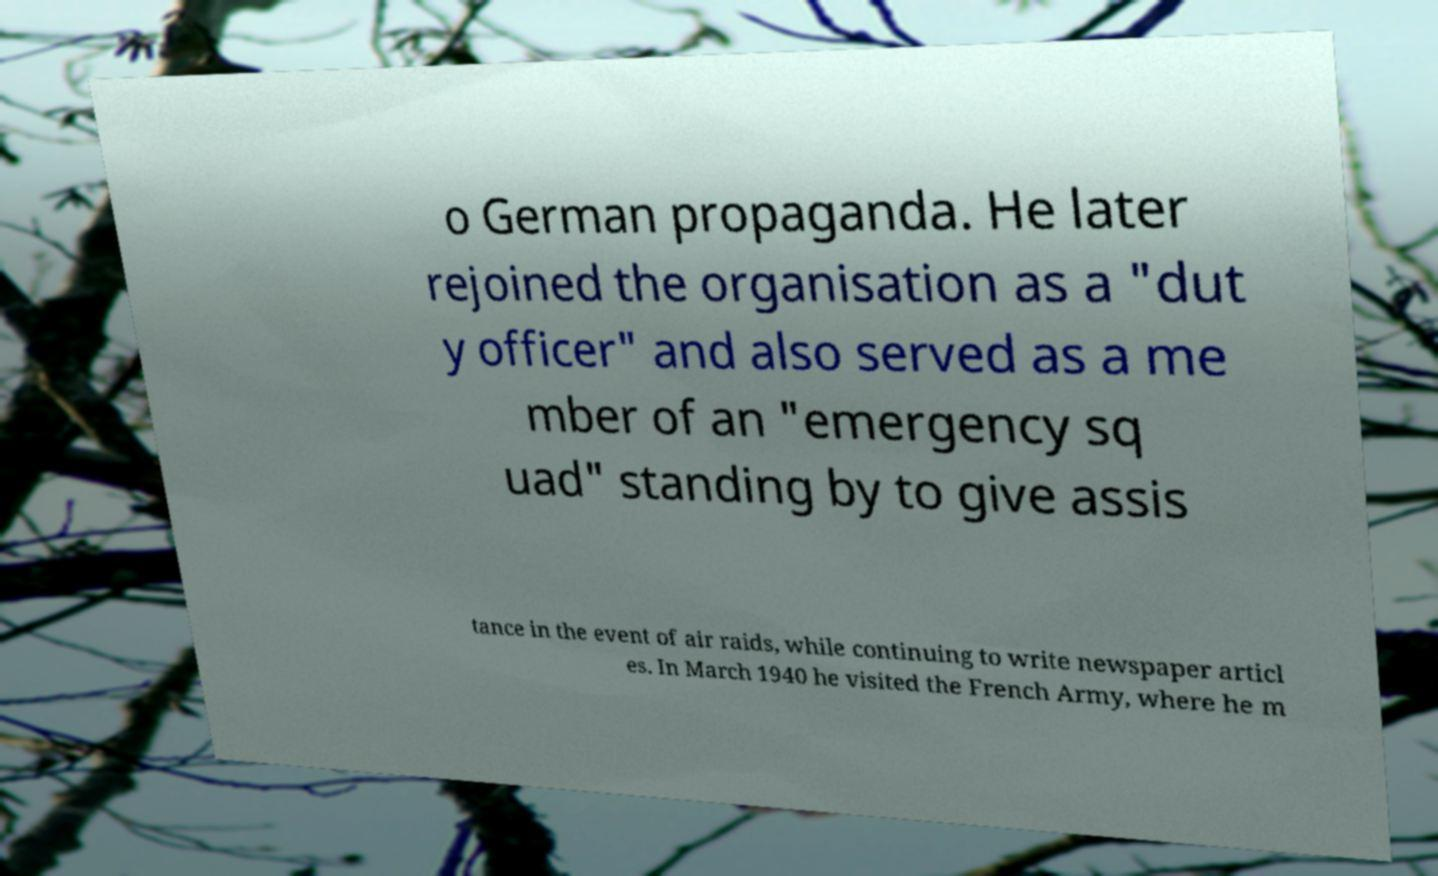What messages or text are displayed in this image? I need them in a readable, typed format. o German propaganda. He later rejoined the organisation as a "dut y officer" and also served as a me mber of an "emergency sq uad" standing by to give assis tance in the event of air raids, while continuing to write newspaper articl es. In March 1940 he visited the French Army, where he m 